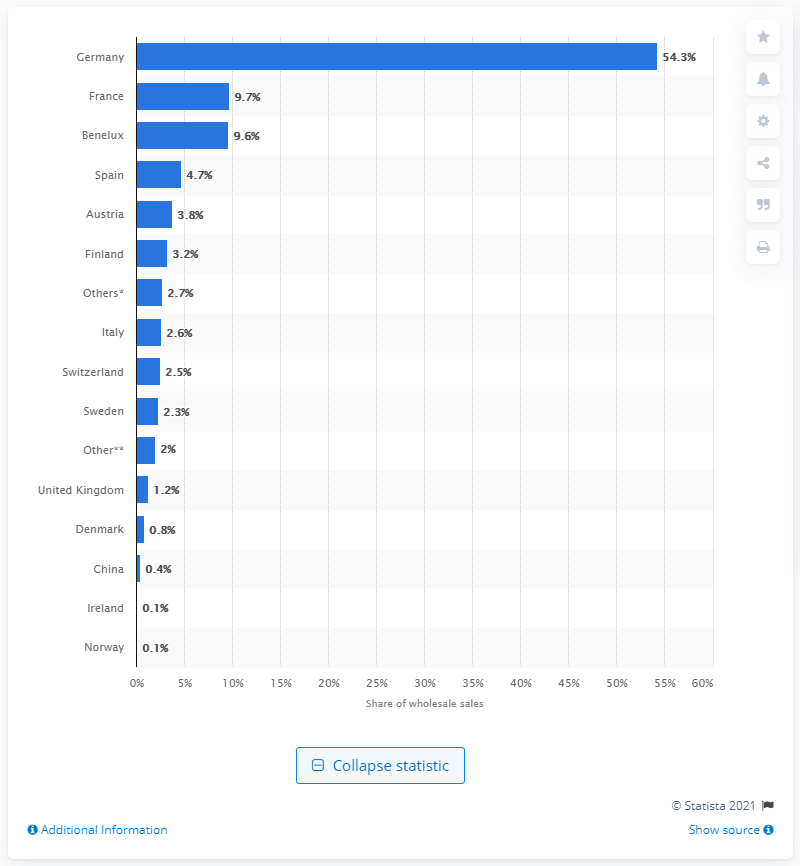List a handful of essential elements in this visual. Out of ESPRIT's wholesale sales, 9.7% were made in France. 